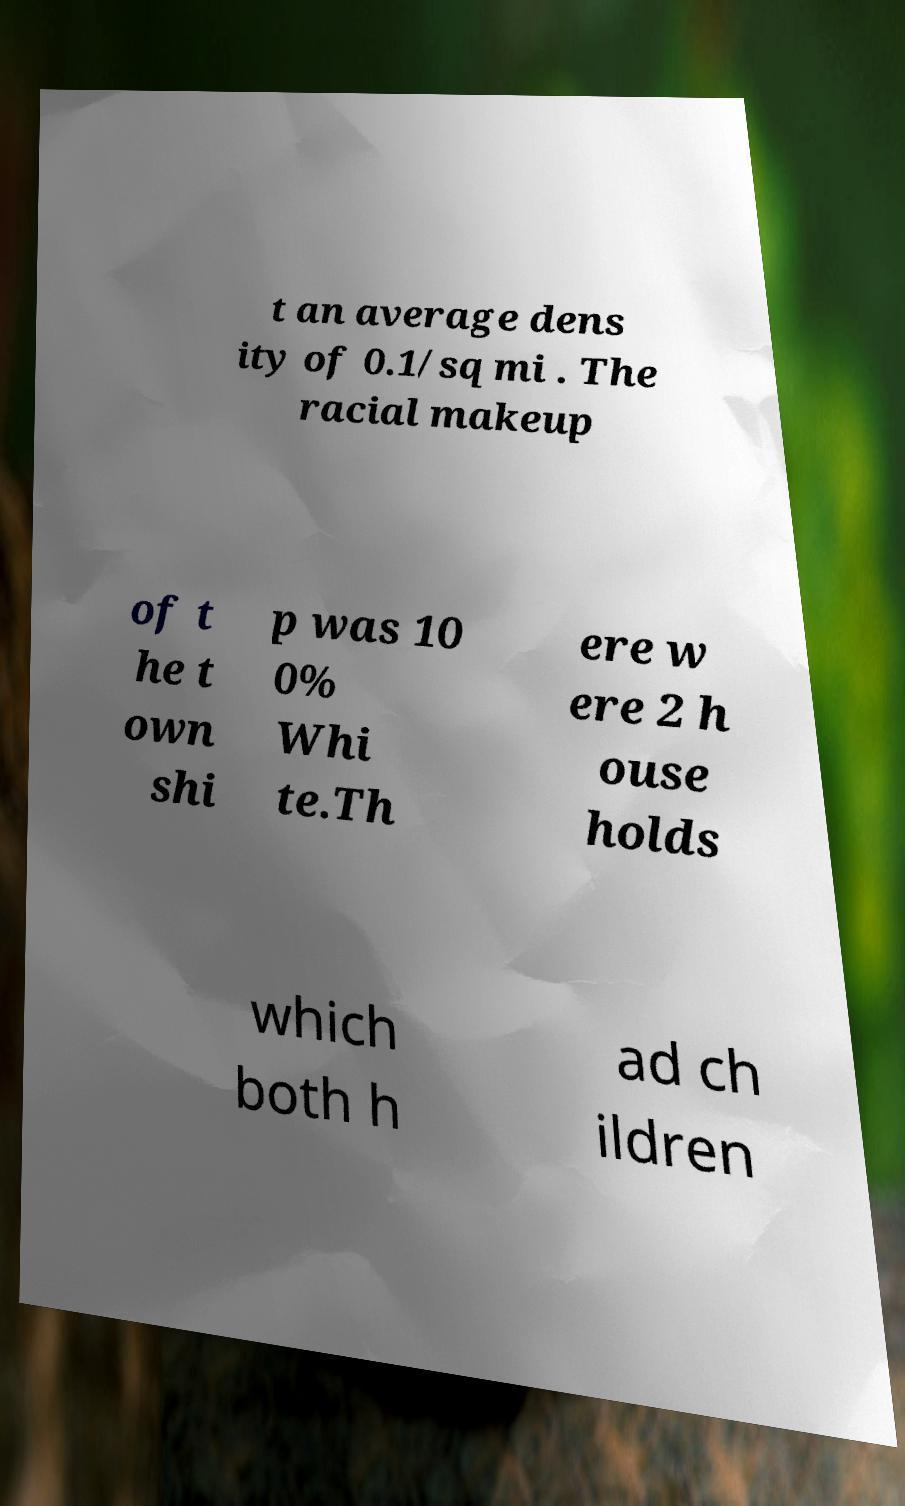Could you extract and type out the text from this image? t an average dens ity of 0.1/sq mi . The racial makeup of t he t own shi p was 10 0% Whi te.Th ere w ere 2 h ouse holds which both h ad ch ildren 